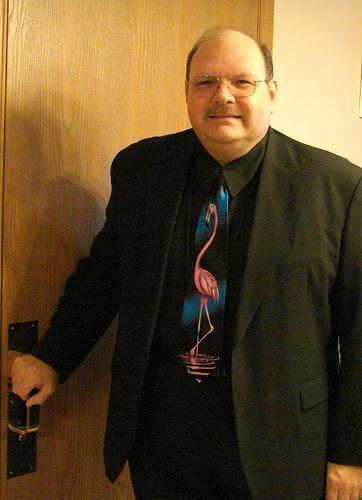How many people are wearing glasses?
Give a very brief answer. 1. 